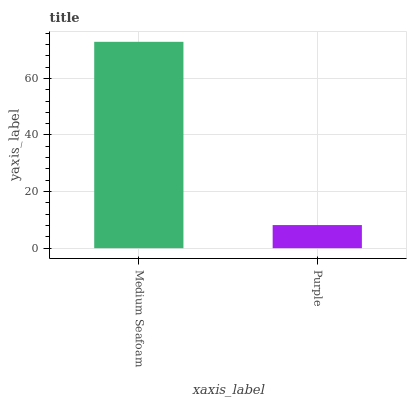Is Purple the maximum?
Answer yes or no. No. Is Medium Seafoam greater than Purple?
Answer yes or no. Yes. Is Purple less than Medium Seafoam?
Answer yes or no. Yes. Is Purple greater than Medium Seafoam?
Answer yes or no. No. Is Medium Seafoam less than Purple?
Answer yes or no. No. Is Medium Seafoam the high median?
Answer yes or no. Yes. Is Purple the low median?
Answer yes or no. Yes. Is Purple the high median?
Answer yes or no. No. Is Medium Seafoam the low median?
Answer yes or no. No. 